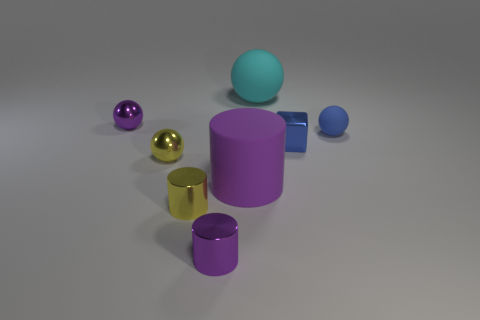How many things are either big rubber spheres or tiny metallic spheres that are in front of the shiny cube?
Offer a terse response. 2. Does the matte object right of the blue block have the same size as the big cylinder?
Offer a very short reply. No. What number of other objects are the same shape as the large purple rubber thing?
Give a very brief answer. 2. How many blue objects are balls or large balls?
Provide a short and direct response. 1. Is the color of the shiny thing to the left of the yellow ball the same as the big rubber cylinder?
Offer a very short reply. Yes. There is a big object that is the same material as the cyan sphere; what shape is it?
Give a very brief answer. Cylinder. The small shiny thing that is to the right of the yellow shiny cylinder and in front of the big purple matte cylinder is what color?
Offer a very short reply. Purple. How big is the object behind the purple shiny thing that is behind the small rubber ball?
Your answer should be compact. Large. Is there a block that has the same color as the tiny rubber sphere?
Your answer should be very brief. Yes. Are there the same number of small yellow shiny things that are right of the tiny blue shiny block and tiny red matte things?
Provide a short and direct response. Yes. 